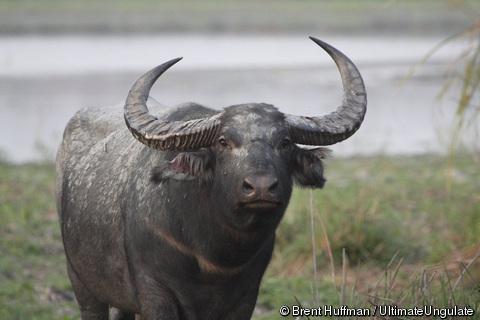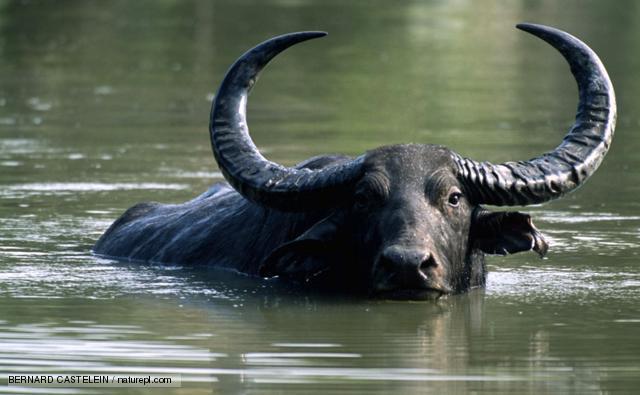The first image is the image on the left, the second image is the image on the right. Evaluate the accuracy of this statement regarding the images: "A body of water is visible in the right image of a water buffalo.". Is it true? Answer yes or no. Yes. 